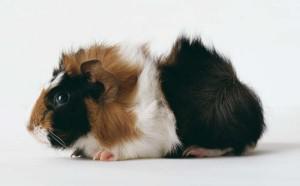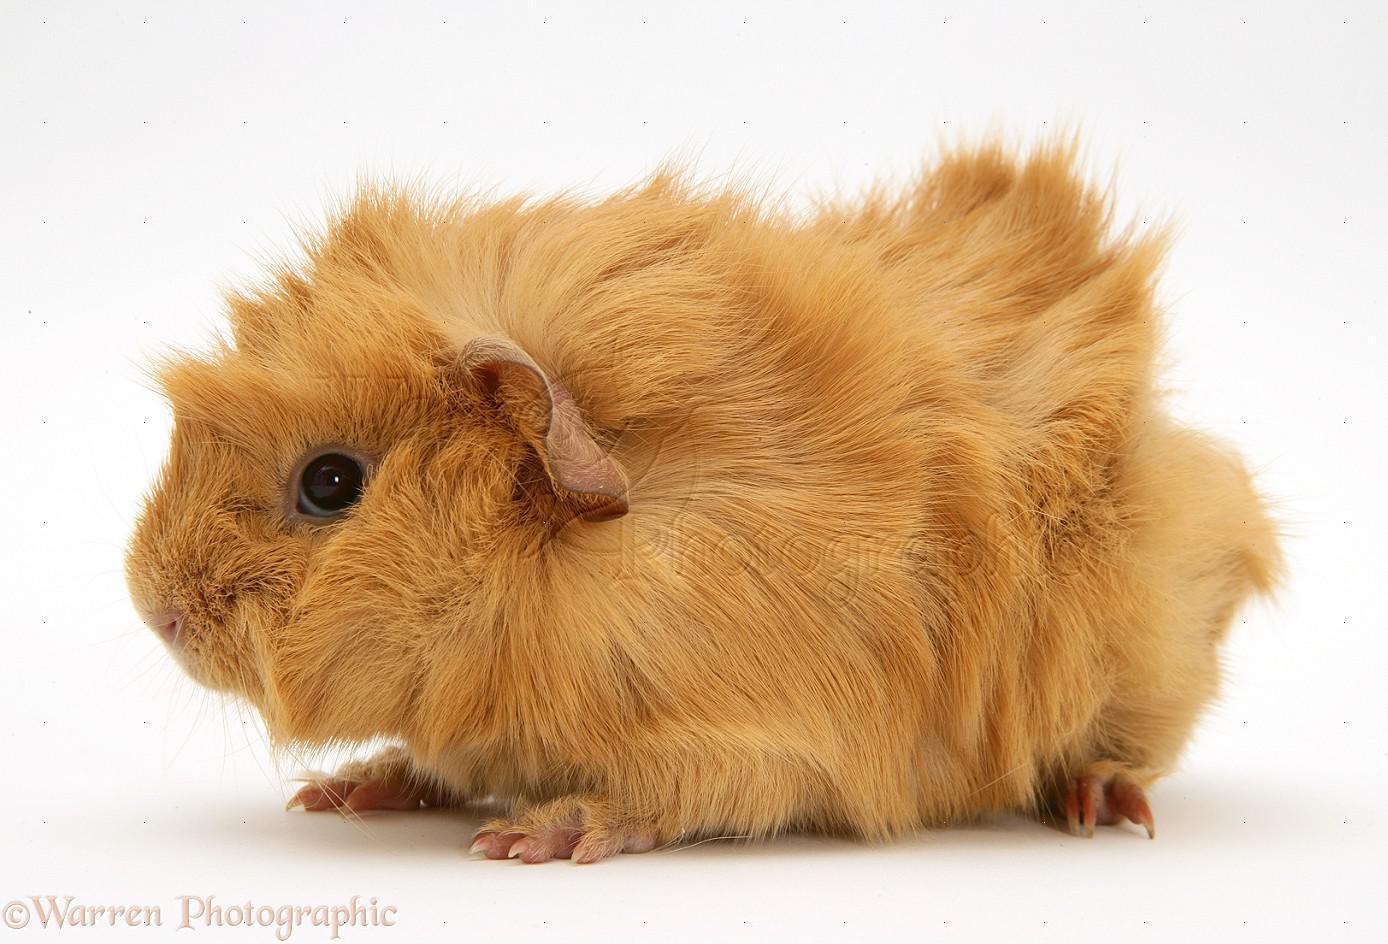The first image is the image on the left, the second image is the image on the right. Evaluate the accuracy of this statement regarding the images: "There are three guinea pigs.". Is it true? Answer yes or no. No. The first image is the image on the left, the second image is the image on the right. Given the left and right images, does the statement "One image contains twice as many guinea pigs as the other hamster, and one image contains something bright green." hold true? Answer yes or no. No. 